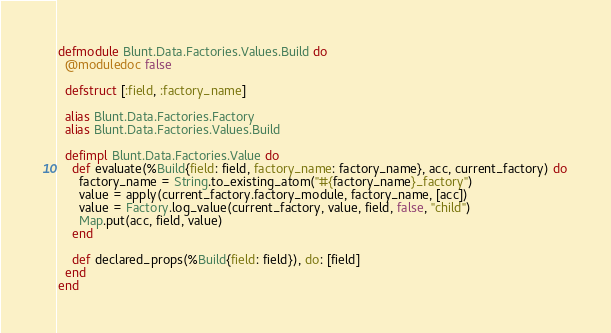<code> <loc_0><loc_0><loc_500><loc_500><_Elixir_>defmodule Blunt.Data.Factories.Values.Build do
  @moduledoc false

  defstruct [:field, :factory_name]

  alias Blunt.Data.Factories.Factory
  alias Blunt.Data.Factories.Values.Build

  defimpl Blunt.Data.Factories.Value do
    def evaluate(%Build{field: field, factory_name: factory_name}, acc, current_factory) do
      factory_name = String.to_existing_atom("#{factory_name}_factory")
      value = apply(current_factory.factory_module, factory_name, [acc])
      value = Factory.log_value(current_factory, value, field, false, "child")
      Map.put(acc, field, value)
    end

    def declared_props(%Build{field: field}), do: [field]
  end
end
</code> 